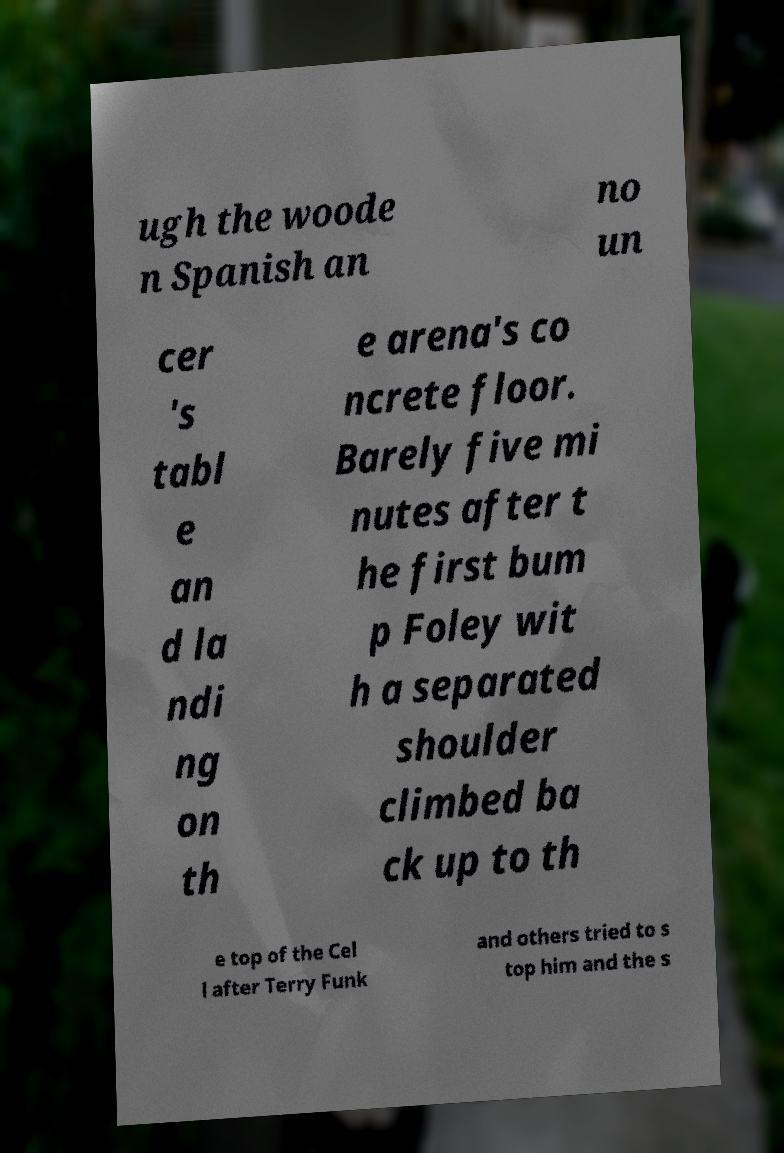I need the written content from this picture converted into text. Can you do that? ugh the woode n Spanish an no un cer 's tabl e an d la ndi ng on th e arena's co ncrete floor. Barely five mi nutes after t he first bum p Foley wit h a separated shoulder climbed ba ck up to th e top of the Cel l after Terry Funk and others tried to s top him and the s 